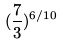<formula> <loc_0><loc_0><loc_500><loc_500>( \frac { 7 } { 3 } ) ^ { 6 / 1 0 }</formula> 